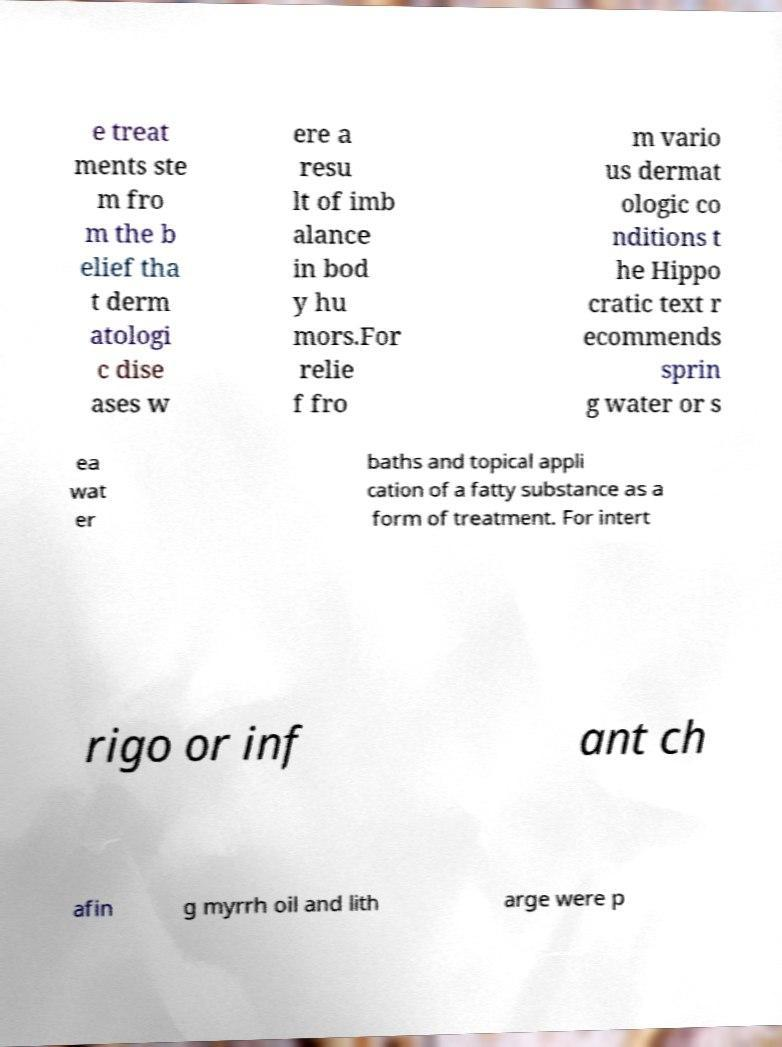Can you read and provide the text displayed in the image?This photo seems to have some interesting text. Can you extract and type it out for me? e treat ments ste m fro m the b elief tha t derm atologi c dise ases w ere a resu lt of imb alance in bod y hu mors.For relie f fro m vario us dermat ologic co nditions t he Hippo cratic text r ecommends sprin g water or s ea wat er baths and topical appli cation of a fatty substance as a form of treatment. For intert rigo or inf ant ch afin g myrrh oil and lith arge were p 